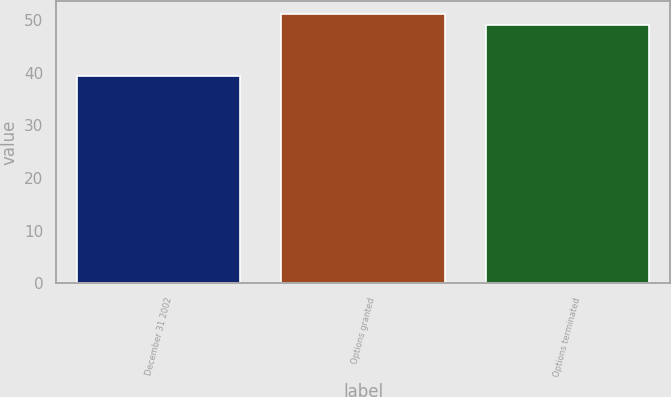<chart> <loc_0><loc_0><loc_500><loc_500><bar_chart><fcel>December 31 2002<fcel>Options granted<fcel>Options terminated<nl><fcel>39.42<fcel>51.08<fcel>49.12<nl></chart> 